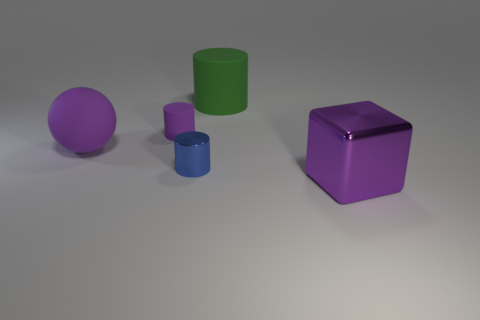Subtract all rubber cylinders. How many cylinders are left? 1 Add 5 matte objects. How many objects exist? 10 Subtract all balls. How many objects are left? 4 Subtract 0 green balls. How many objects are left? 5 Subtract all large rubber objects. Subtract all big objects. How many objects are left? 0 Add 1 metal cylinders. How many metal cylinders are left? 2 Add 4 rubber blocks. How many rubber blocks exist? 4 